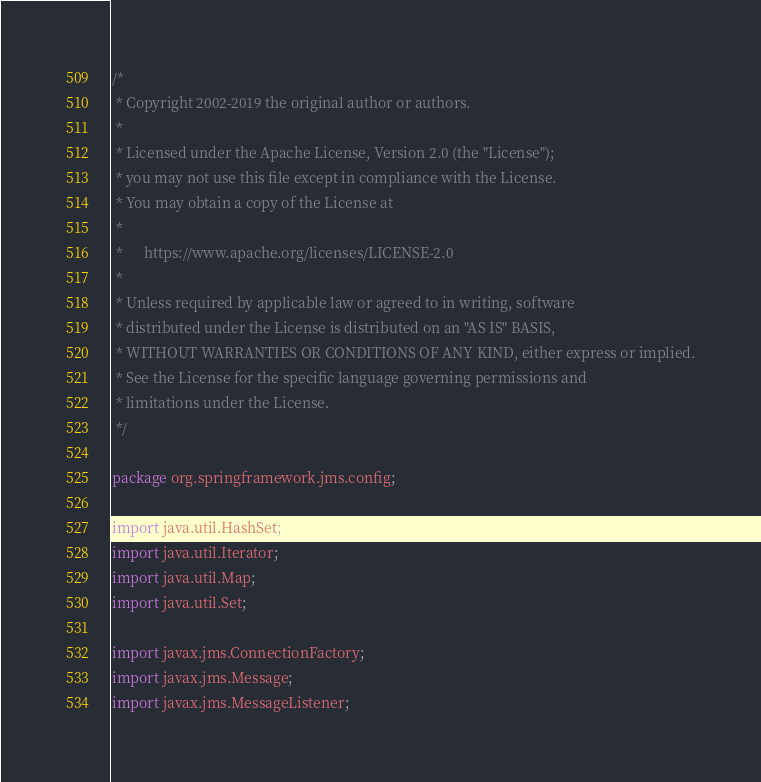Convert code to text. <code><loc_0><loc_0><loc_500><loc_500><_Java_>/*
 * Copyright 2002-2019 the original author or authors.
 *
 * Licensed under the Apache License, Version 2.0 (the "License");
 * you may not use this file except in compliance with the License.
 * You may obtain a copy of the License at
 *
 *      https://www.apache.org/licenses/LICENSE-2.0
 *
 * Unless required by applicable law or agreed to in writing, software
 * distributed under the License is distributed on an "AS IS" BASIS,
 * WITHOUT WARRANTIES OR CONDITIONS OF ANY KIND, either express or implied.
 * See the License for the specific language governing permissions and
 * limitations under the License.
 */

package org.springframework.jms.config;

import java.util.HashSet;
import java.util.Iterator;
import java.util.Map;
import java.util.Set;

import javax.jms.ConnectionFactory;
import javax.jms.Message;
import javax.jms.MessageListener;</code> 